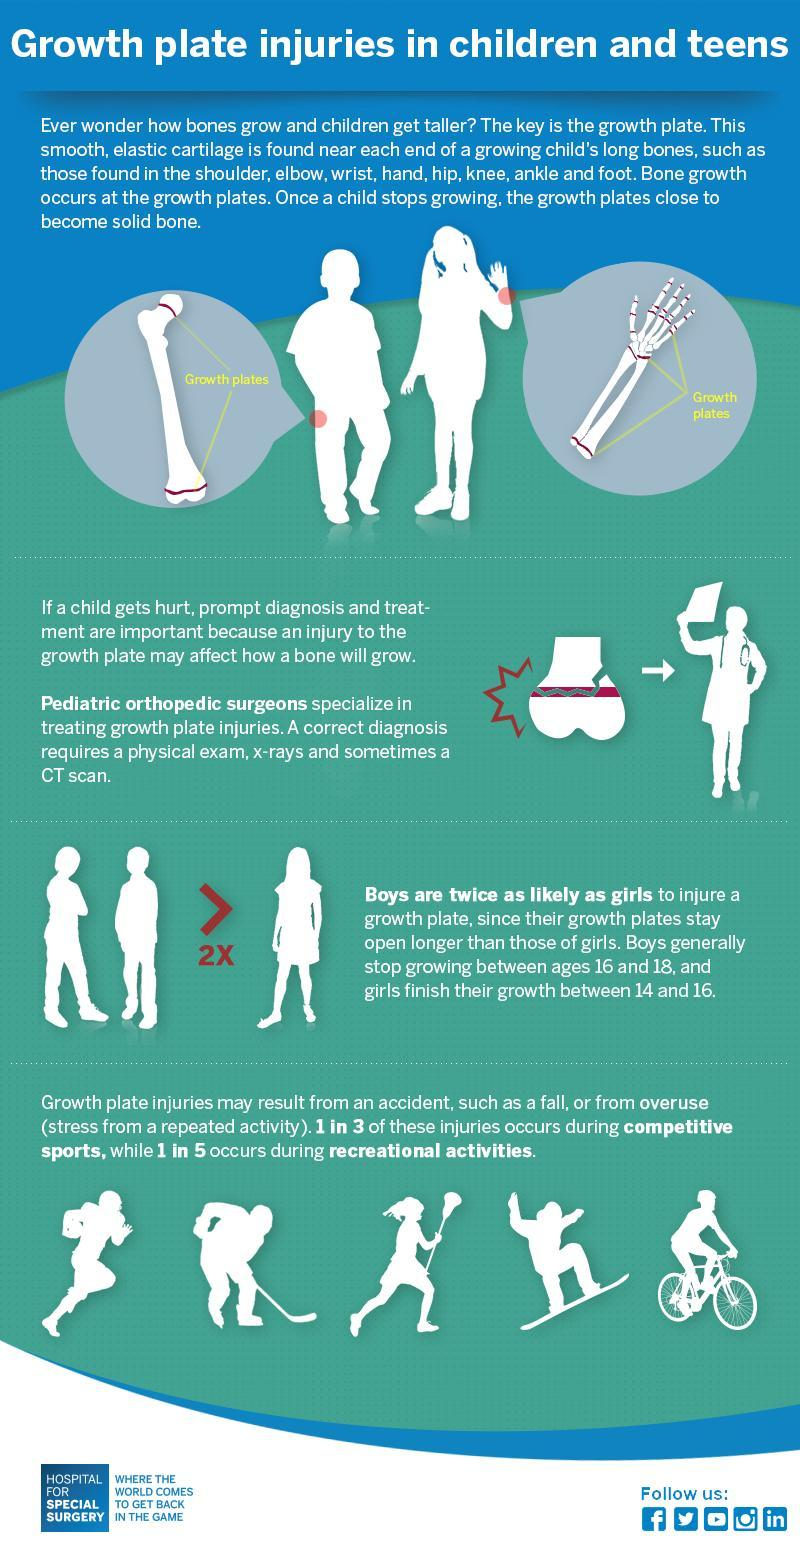How many male icons are in this infographic?
Answer the question with a short phrase. 8 What is the color of the bicycle-red, white or green? white Which color is used to write 2x in this infographic-green, red, white, or blue? red How many female icons are in this infographic? 3 